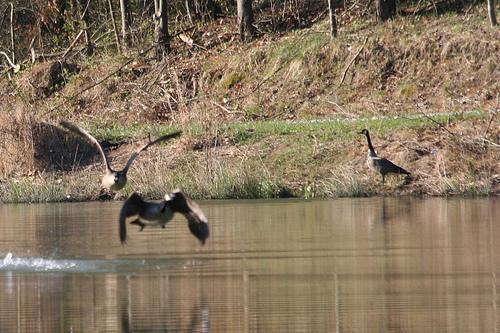These animals have an impressive what?
Answer the question by selecting the correct answer among the 4 following choices.
Options: Stinger, quill, wingspan, tusk. Wingspan. 